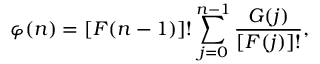<formula> <loc_0><loc_0><loc_500><loc_500>\varphi ( n ) = [ F ( n - 1 ) ] ! \sum _ { j = 0 } ^ { n - 1 } \frac { G ( j ) } { [ F ( j ) ] ! } ,</formula> 